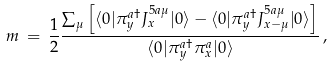<formula> <loc_0><loc_0><loc_500><loc_500>m \, = \, \frac { 1 } { 2 } \frac { \sum _ { \mu } \left [ \langle 0 | \pi _ { y } ^ { a \dagger } J _ { x } ^ { 5 a \mu } | 0 \rangle - \langle 0 | \pi _ { y } ^ { a \dagger } J _ { x - \mu } ^ { 5 a \mu } | 0 \rangle \right ] } { \langle 0 | \pi _ { y } ^ { a \dagger } \pi _ { x } ^ { a } | 0 \rangle } \, ,</formula> 